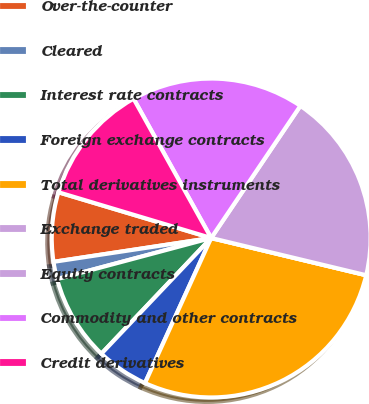<chart> <loc_0><loc_0><loc_500><loc_500><pie_chart><fcel>Over-the-counter<fcel>Cleared<fcel>Interest rate contracts<fcel>Foreign exchange contracts<fcel>Total derivatives instruments<fcel>Exchange traded<fcel>Equity contracts<fcel>Commodity and other contracts<fcel>Credit derivatives<nl><fcel>7.02%<fcel>1.76%<fcel>8.77%<fcel>5.27%<fcel>28.06%<fcel>0.0%<fcel>19.3%<fcel>17.54%<fcel>12.28%<nl></chart> 